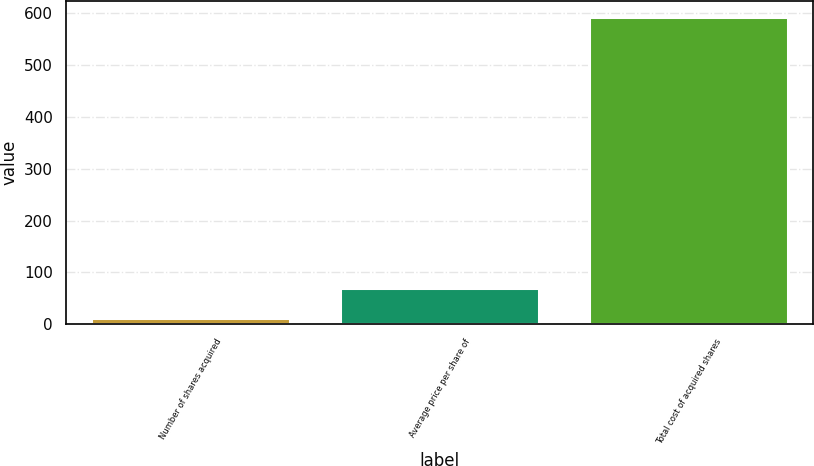<chart> <loc_0><loc_0><loc_500><loc_500><bar_chart><fcel>Number of shares acquired<fcel>Average price per share of<fcel>Total cost of acquired shares<nl><fcel>12.3<fcel>70.39<fcel>593.2<nl></chart> 